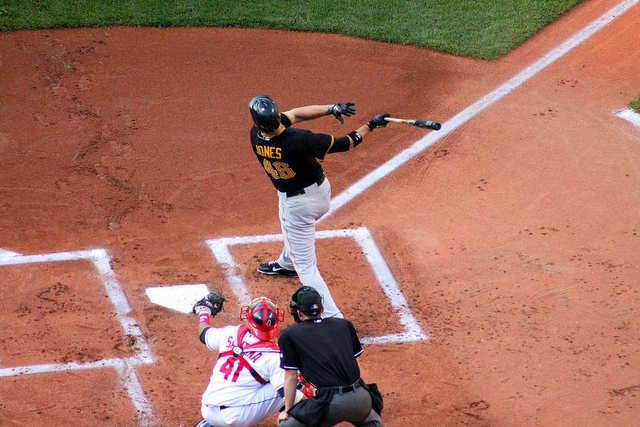Describe the objects in this image and their specific colors. I can see people in darkgreen, black, lightgray, darkgray, and brown tones, people in darkgreen, black, gray, and brown tones, people in darkgreen, lavender, brown, and salmon tones, baseball glove in darkgreen, black, lightgray, gray, and darkgray tones, and baseball bat in darkgreen, black, gray, brown, and beige tones in this image. 